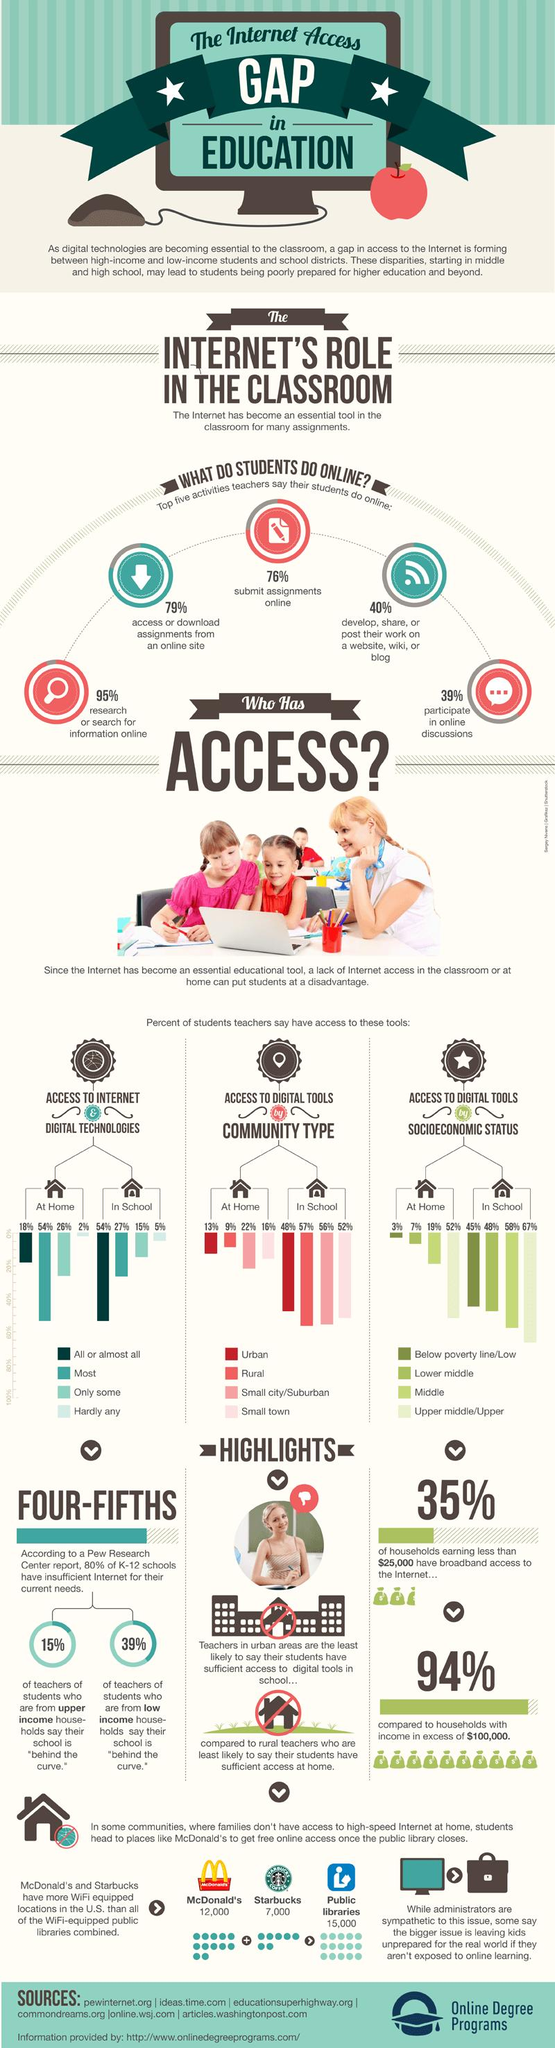Identify some key points in this picture. According to recent studies, only 5% of U.S. students have limited or no access to digital technologies at school. According to recent data, a staggering 95% of U.S. students regularly research or search for online information. According to recent statistics, approximately 45% of students in schools in the United States live below the poverty line. There are approximately 7,000 Starbucks locations in the United States that offer WiFi access to customers. In the United States, 18% of students have access to all types of digital technologies at home. 